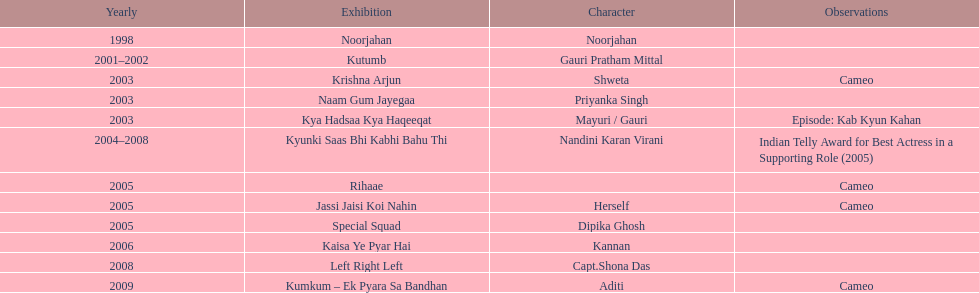What was the first tv series that gauri tejwani appeared in? Noorjahan. 